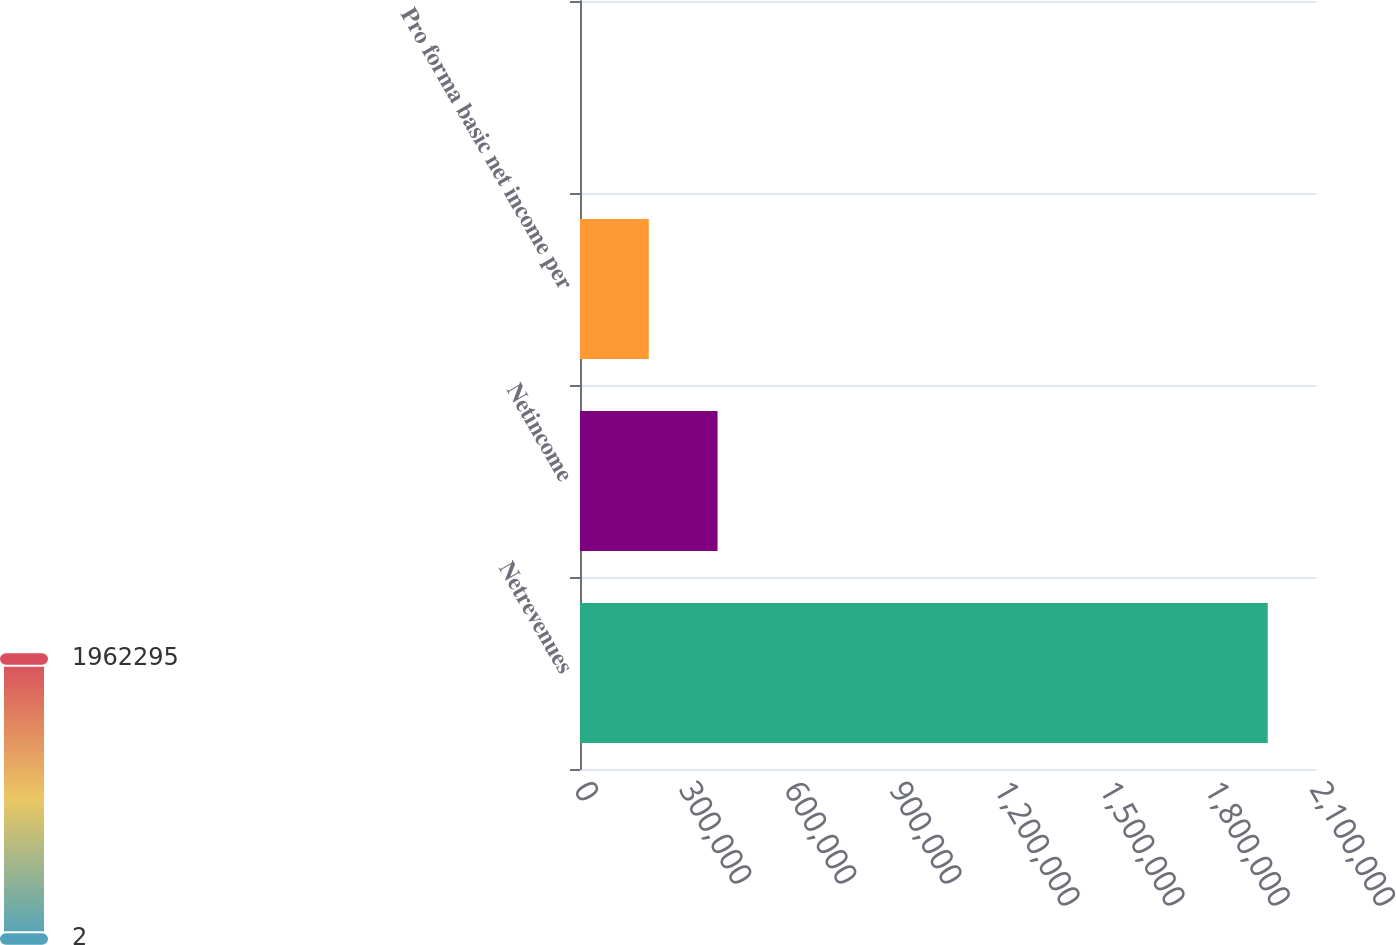<chart> <loc_0><loc_0><loc_500><loc_500><bar_chart><fcel>Netrevenues<fcel>Netincome<fcel>Pro forma basic net income per<fcel>Unnamed: 3<nl><fcel>1.9623e+06<fcel>392461<fcel>196231<fcel>2.05<nl></chart> 